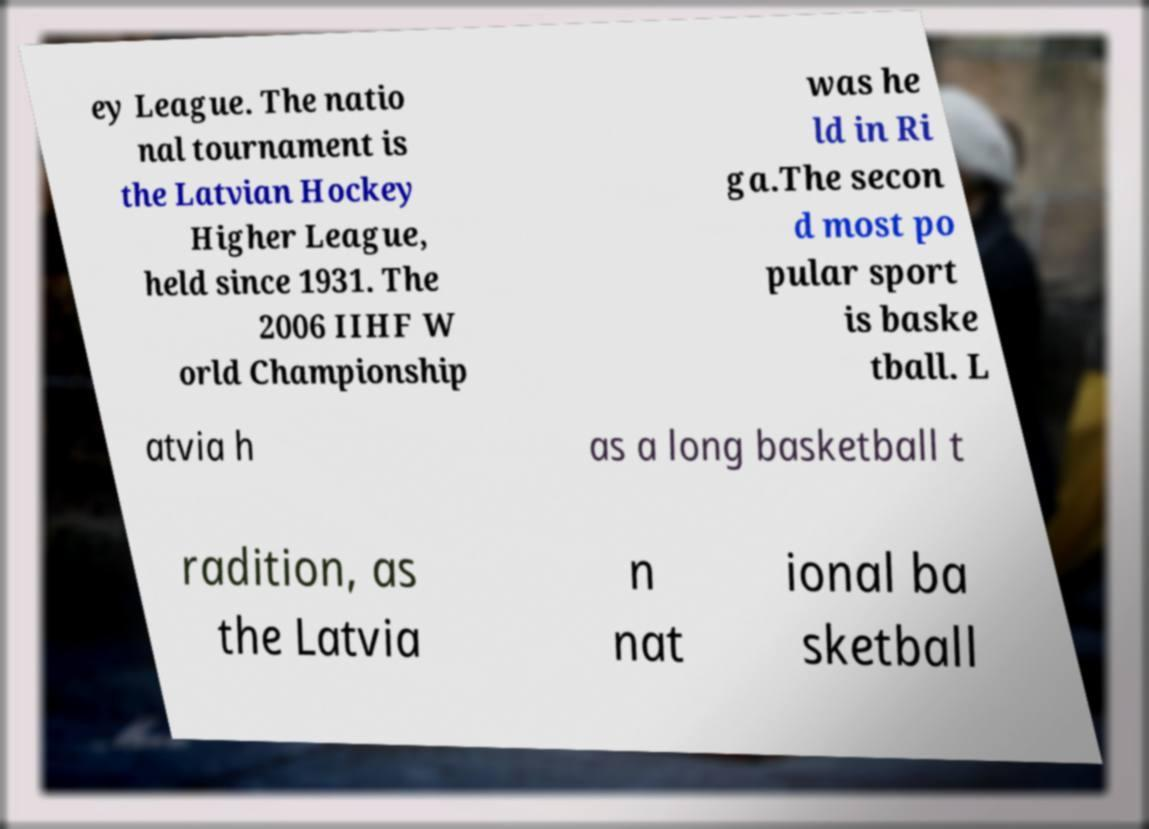Can you read and provide the text displayed in the image?This photo seems to have some interesting text. Can you extract and type it out for me? ey League. The natio nal tournament is the Latvian Hockey Higher League, held since 1931. The 2006 IIHF W orld Championship was he ld in Ri ga.The secon d most po pular sport is baske tball. L atvia h as a long basketball t radition, as the Latvia n nat ional ba sketball 